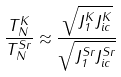Convert formula to latex. <formula><loc_0><loc_0><loc_500><loc_500>\frac { T _ { N } ^ { K } } { T _ { N } ^ { S r } } \approx \frac { \sqrt { J _ { 1 } ^ { K } J _ { i c } ^ { K } } } { \sqrt { J _ { 1 } ^ { S r } J _ { i c } ^ { S r } } }</formula> 